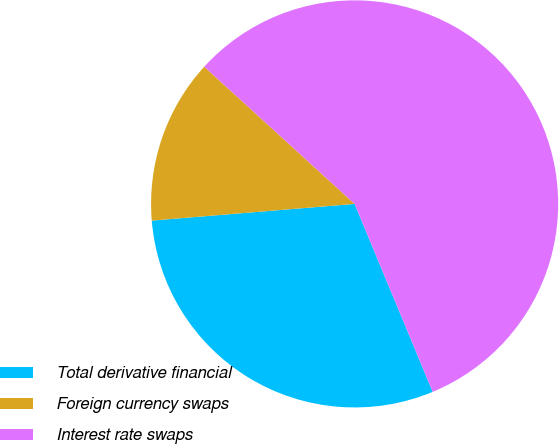<chart> <loc_0><loc_0><loc_500><loc_500><pie_chart><fcel>Total derivative financial<fcel>Foreign currency swaps<fcel>Interest rate swaps<nl><fcel>29.96%<fcel>13.08%<fcel>56.96%<nl></chart> 